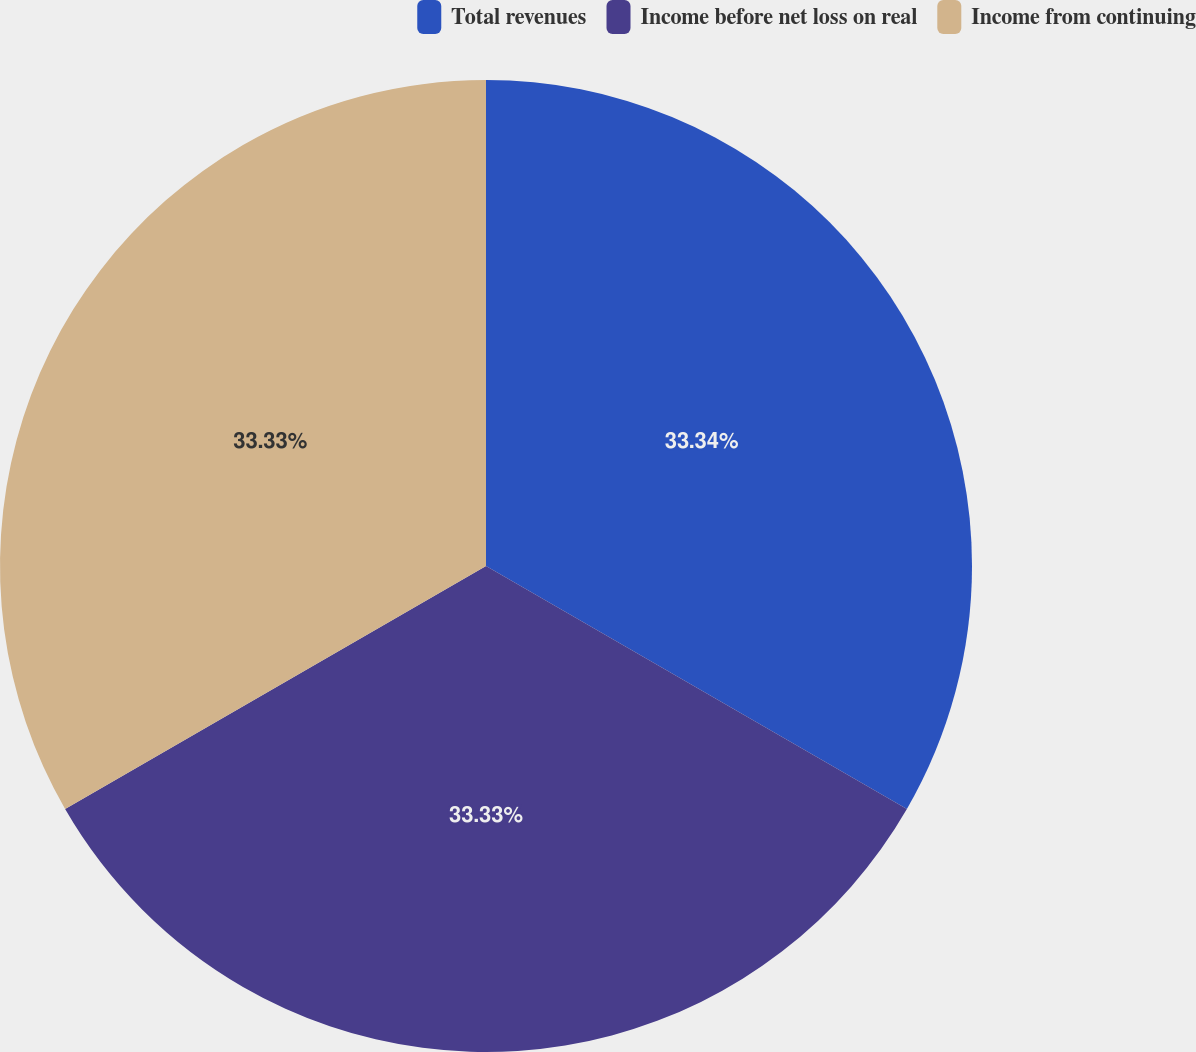Convert chart. <chart><loc_0><loc_0><loc_500><loc_500><pie_chart><fcel>Total revenues<fcel>Income before net loss on real<fcel>Income from continuing<nl><fcel>33.33%<fcel>33.33%<fcel>33.33%<nl></chart> 